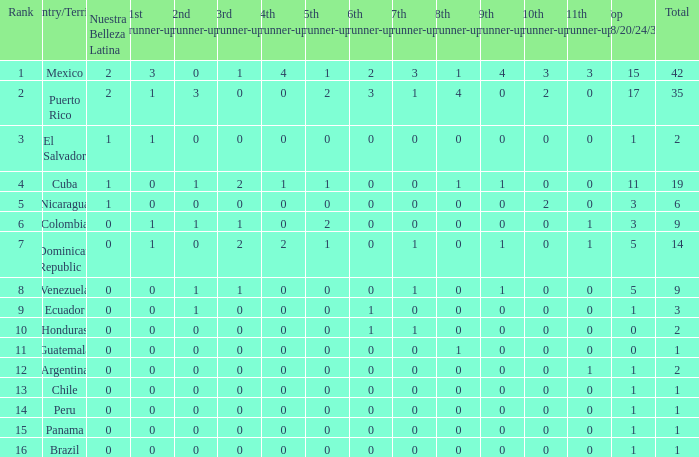What is the sum total of 3rd runners-up in the nation ranking under 4.0. 